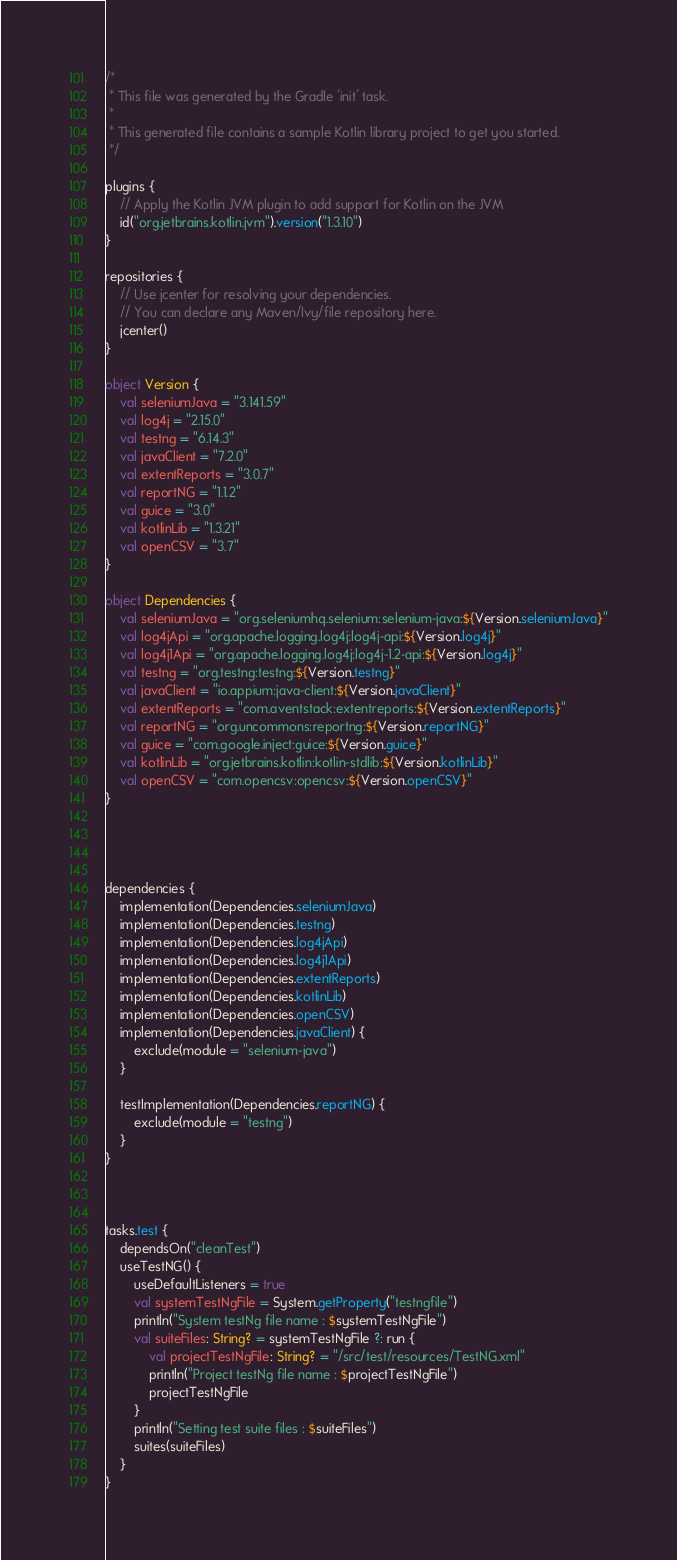Convert code to text. <code><loc_0><loc_0><loc_500><loc_500><_Kotlin_>/*
 * This file was generated by the Gradle 'init' task.
 *
 * This generated file contains a sample Kotlin library project to get you started.
 */

plugins {
    // Apply the Kotlin JVM plugin to add support for Kotlin on the JVM
    id("org.jetbrains.kotlin.jvm").version("1.3.10")
}

repositories {
    // Use jcenter for resolving your dependencies.
    // You can declare any Maven/Ivy/file repository here.
    jcenter()
}

object Version {
    val seleniumJava = "3.141.59"
    val log4j = "2.15.0"
    val testng = "6.14.3"
    val javaClient = "7.2.0"
    val extentReports = "3.0.7"
    val reportNG = "1.1.2"
    val guice = "3.0"
    val kotlinLib = "1.3.21"
    val openCSV = "3.7"
}

object Dependencies {
    val seleniumJava = "org.seleniumhq.selenium:selenium-java:${Version.seleniumJava}"
    val log4jApi = "org.apache.logging.log4j:log4j-api:${Version.log4j}"
    val log4j1Api = "org.apache.logging.log4j:log4j-1.2-api:${Version.log4j}"
    val testng = "org.testng:testng:${Version.testng}"
    val javaClient = "io.appium:java-client:${Version.javaClient}"
    val extentReports = "com.aventstack:extentreports:${Version.extentReports}"
    val reportNG = "org.uncommons:reportng:${Version.reportNG}"
    val guice = "com.google.inject:guice:${Version.guice}"
    val kotlinLib = "org.jetbrains.kotlin:kotlin-stdlib:${Version.kotlinLib}"
    val openCSV = "com.opencsv:opencsv:${Version.openCSV}"
}




dependencies {
    implementation(Dependencies.seleniumJava)
    implementation(Dependencies.testng)
    implementation(Dependencies.log4jApi)
    implementation(Dependencies.log4j1Api)
    implementation(Dependencies.extentReports)
    implementation(Dependencies.kotlinLib)
    implementation(Dependencies.openCSV)
    implementation(Dependencies.javaClient) {
        exclude(module = "selenium-java")
    }

    testImplementation(Dependencies.reportNG) {
        exclude(module = "testng")
    }
}



tasks.test {
    dependsOn("cleanTest")
    useTestNG() {
        useDefaultListeners = true
        val systemTestNgFile = System.getProperty("testngfile")
        println("System testNg file name : $systemTestNgFile")
        val suiteFiles: String? = systemTestNgFile ?: run {
            val projectTestNgFile: String? = "/src/test/resources/TestNG.xml"
            println("Project testNg file name : $projectTestNgFile")
            projectTestNgFile
        }
        println("Setting test suite files : $suiteFiles")
        suites(suiteFiles)
    }
}
</code> 